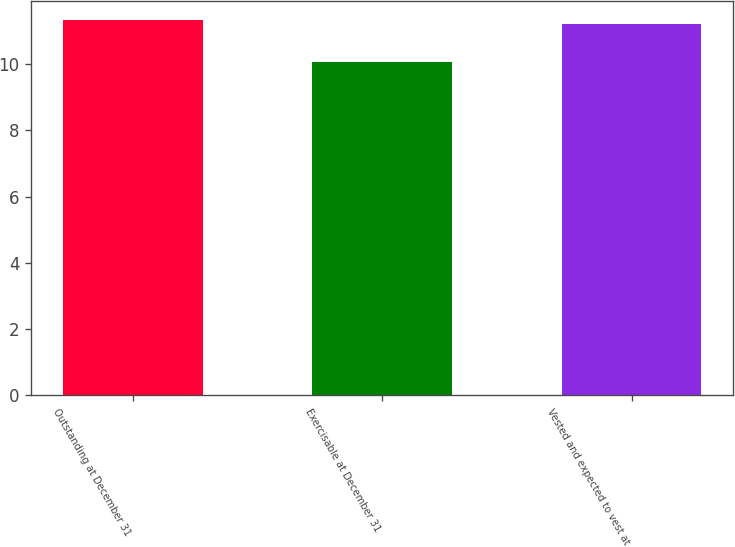<chart> <loc_0><loc_0><loc_500><loc_500><bar_chart><fcel>Outstanding at December 31<fcel>Exercisable at December 31<fcel>Vested and expected to vest at<nl><fcel>11.33<fcel>10.07<fcel>11.21<nl></chart> 